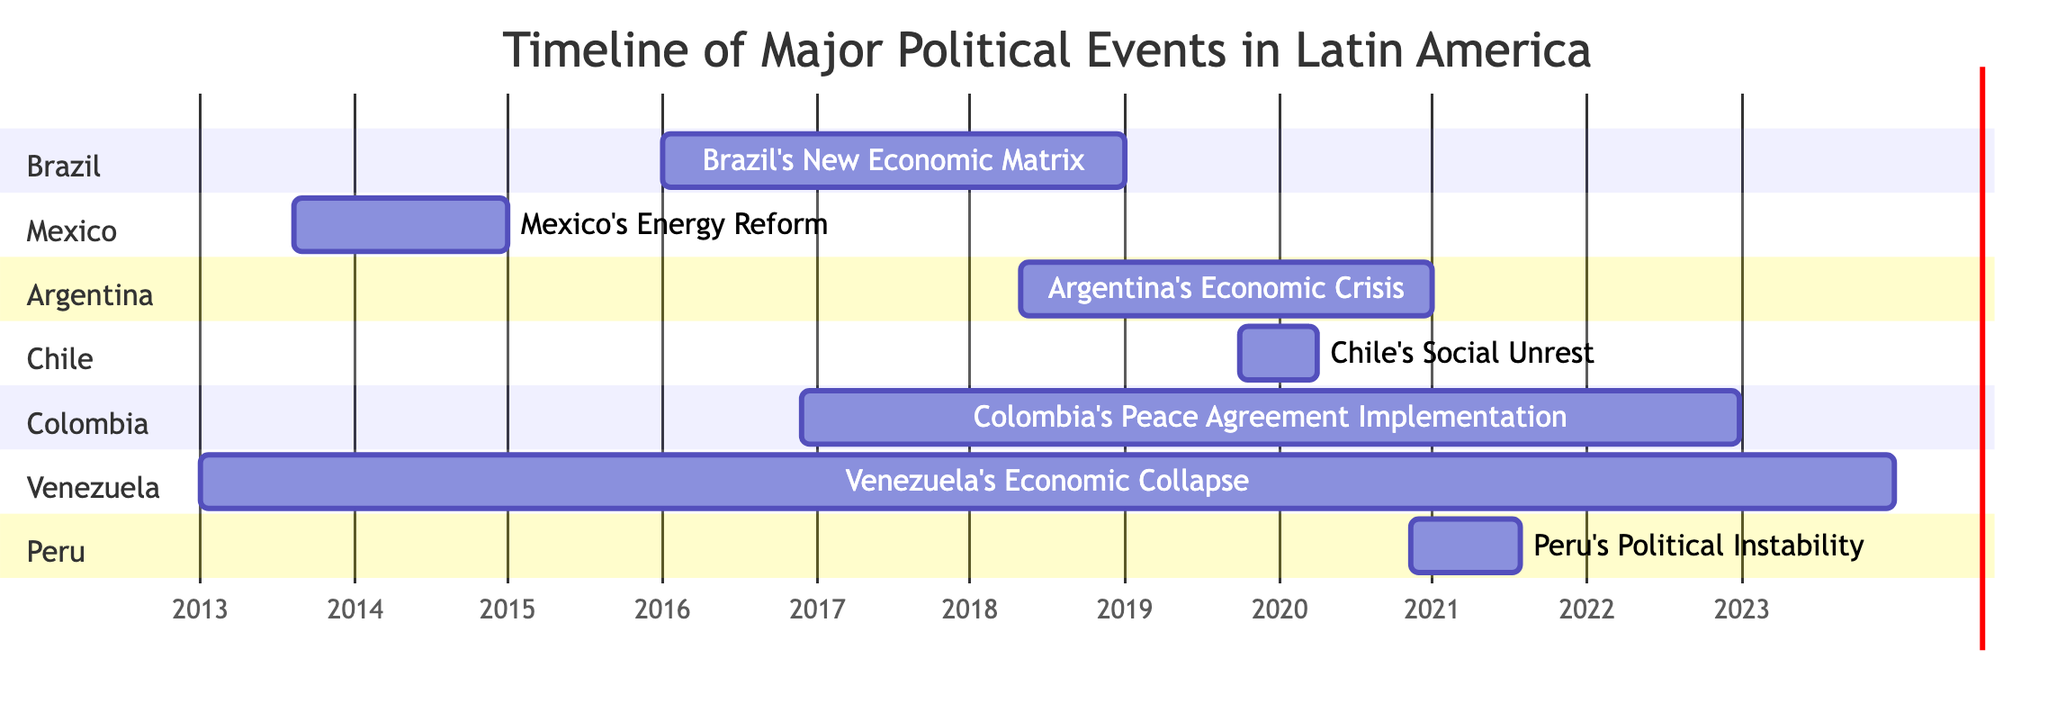what event occurred in Brazil during 2016 to 2018? The diagram shows "Brazil's New Economic Matrix" spanning from January 1, 2016, to December 31, 2018, indicating that this event took place within that timeframe in Brazil.
Answer: Brazil's New Economic Matrix how long did Venezuela's economic collapse last? The diagram indicates the starting date is January 1, 2013, and extends to December 31, 2023. By calculating the duration from start to end, it spans 11 years.
Answer: 11 years what is the starting month of Mexico's Energy Reform? The diagram shows that "Mexico's Energy Reform" started on August 12, 2013. This is the specific date presented in the chart.
Answer: August which two events overlap in Colombia between 2016 and 2022? In the diagram, "Colombia's Peace Agreement Implementation" runs from November 24, 2016, to December 31, 2022. The only overlapping event is "Brazil's New Economic Matrix" from January 1, 2016, to December 31, 2018. Therefore, these two events are identified as overlapping.
Answer: Brazil's New Economic Matrix how many political events are shown in the diagram? Counting each event in the sections of the diagram, there are a total of 7 political events represented.
Answer: 7 what is the last event listed in the diagram? The diagram's list concludes with "Peru's Political Instability," which has the end date of July 28, 2021, making it the last event presented.
Answer: Peru's Political Instability during which event did Chile experience major social unrest? According to the diagram, "Chile's Social Unrest" took place from October 1, 2019, to March 31, 2020, outlining when this unrest occurred.
Answer: Chile's Social Unrest which country faced an economic crisis starting in May 2018? The diagram highlights "Argentina's Economic Crisis" commencing on May 1, 2018, specifically noting this event's timeline in Argentina.
Answer: Argentina 